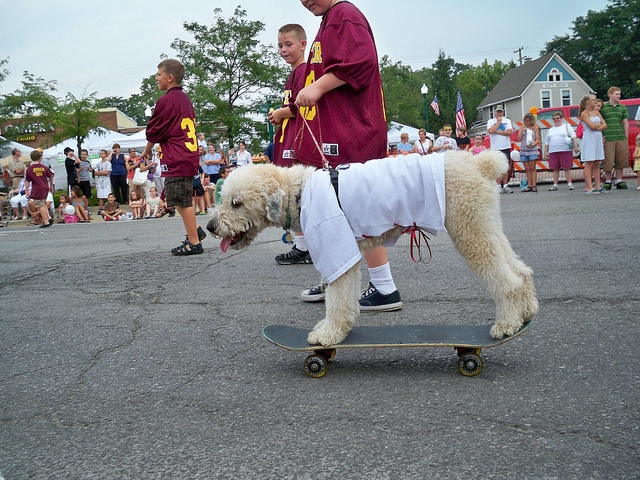Describe the objects in this image and their specific colors. I can see dog in lightblue, darkgray, lightgray, and gray tones, people in lightblue, maroon, purple, black, and brown tones, people in lightblue, darkgray, gray, lightgray, and brown tones, skateboard in lightblue, gray, black, darkgray, and olive tones, and people in lightblue, maroon, black, brown, and purple tones in this image. 